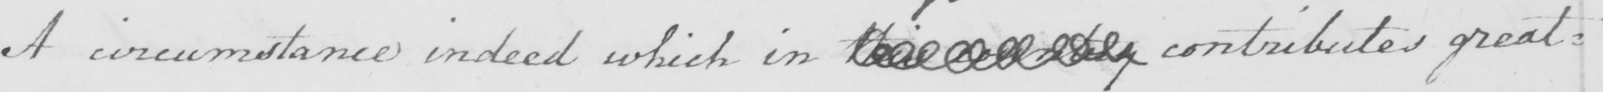What text is written in this handwritten line? A circumstance indeed which in this country contributes great= 